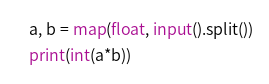Convert code to text. <code><loc_0><loc_0><loc_500><loc_500><_Python_>a, b = map(float, input().split())
print(int(a*b))</code> 